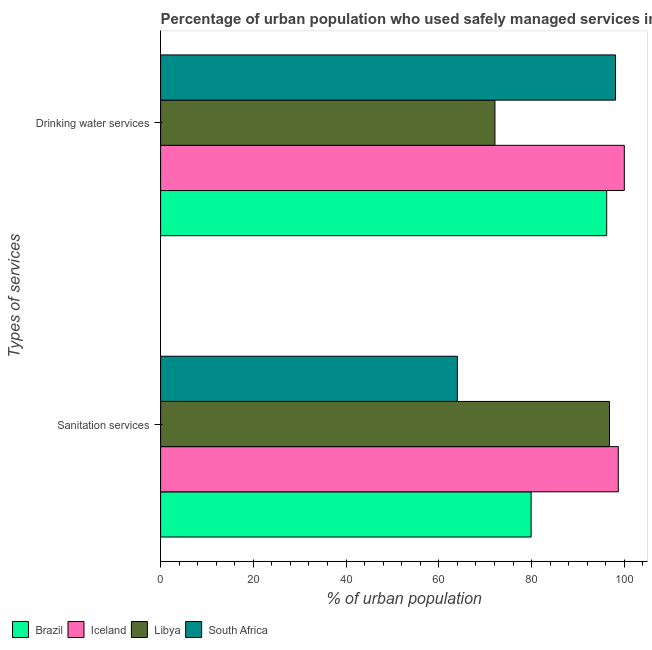How many groups of bars are there?
Offer a very short reply. 2. What is the label of the 2nd group of bars from the top?
Provide a short and direct response. Sanitation services. In which country was the percentage of urban population who used sanitation services minimum?
Make the answer very short. South Africa. What is the total percentage of urban population who used drinking water services in the graph?
Give a very brief answer. 366.4. What is the difference between the percentage of urban population who used drinking water services in Libya and that in Brazil?
Provide a short and direct response. -24.1. What is the difference between the percentage of urban population who used sanitation services in Brazil and the percentage of urban population who used drinking water services in South Africa?
Keep it short and to the point. -18.2. What is the average percentage of urban population who used sanitation services per country?
Offer a very short reply. 84.85. What is the difference between the percentage of urban population who used drinking water services and percentage of urban population who used sanitation services in Brazil?
Make the answer very short. 16.3. In how many countries, is the percentage of urban population who used drinking water services greater than 88 %?
Your answer should be very brief. 3. What does the 2nd bar from the top in Sanitation services represents?
Keep it short and to the point. Libya. What does the 4th bar from the bottom in Sanitation services represents?
Ensure brevity in your answer.  South Africa. Are the values on the major ticks of X-axis written in scientific E-notation?
Offer a terse response. No. Does the graph contain grids?
Ensure brevity in your answer.  No. How many legend labels are there?
Provide a succinct answer. 4. How are the legend labels stacked?
Keep it short and to the point. Horizontal. What is the title of the graph?
Offer a terse response. Percentage of urban population who used safely managed services in 1992. What is the label or title of the X-axis?
Your response must be concise. % of urban population. What is the label or title of the Y-axis?
Provide a succinct answer. Types of services. What is the % of urban population in Brazil in Sanitation services?
Give a very brief answer. 79.9. What is the % of urban population of Iceland in Sanitation services?
Offer a terse response. 98.7. What is the % of urban population of Libya in Sanitation services?
Your answer should be compact. 96.8. What is the % of urban population of South Africa in Sanitation services?
Your response must be concise. 64. What is the % of urban population in Brazil in Drinking water services?
Provide a succinct answer. 96.2. What is the % of urban population of Iceland in Drinking water services?
Ensure brevity in your answer.  100. What is the % of urban population of Libya in Drinking water services?
Provide a succinct answer. 72.1. What is the % of urban population of South Africa in Drinking water services?
Your response must be concise. 98.1. Across all Types of services, what is the maximum % of urban population in Brazil?
Give a very brief answer. 96.2. Across all Types of services, what is the maximum % of urban population of Iceland?
Give a very brief answer. 100. Across all Types of services, what is the maximum % of urban population in Libya?
Your response must be concise. 96.8. Across all Types of services, what is the maximum % of urban population of South Africa?
Offer a very short reply. 98.1. Across all Types of services, what is the minimum % of urban population in Brazil?
Your answer should be very brief. 79.9. Across all Types of services, what is the minimum % of urban population in Iceland?
Your answer should be very brief. 98.7. Across all Types of services, what is the minimum % of urban population of Libya?
Offer a very short reply. 72.1. Across all Types of services, what is the minimum % of urban population in South Africa?
Offer a very short reply. 64. What is the total % of urban population of Brazil in the graph?
Provide a short and direct response. 176.1. What is the total % of urban population of Iceland in the graph?
Provide a short and direct response. 198.7. What is the total % of urban population in Libya in the graph?
Offer a terse response. 168.9. What is the total % of urban population in South Africa in the graph?
Offer a very short reply. 162.1. What is the difference between the % of urban population of Brazil in Sanitation services and that in Drinking water services?
Provide a succinct answer. -16.3. What is the difference between the % of urban population in Libya in Sanitation services and that in Drinking water services?
Provide a short and direct response. 24.7. What is the difference between the % of urban population in South Africa in Sanitation services and that in Drinking water services?
Make the answer very short. -34.1. What is the difference between the % of urban population in Brazil in Sanitation services and the % of urban population in Iceland in Drinking water services?
Offer a very short reply. -20.1. What is the difference between the % of urban population of Brazil in Sanitation services and the % of urban population of South Africa in Drinking water services?
Your answer should be compact. -18.2. What is the difference between the % of urban population of Iceland in Sanitation services and the % of urban population of Libya in Drinking water services?
Offer a very short reply. 26.6. What is the difference between the % of urban population of Iceland in Sanitation services and the % of urban population of South Africa in Drinking water services?
Keep it short and to the point. 0.6. What is the average % of urban population in Brazil per Types of services?
Your answer should be compact. 88.05. What is the average % of urban population of Iceland per Types of services?
Your answer should be very brief. 99.35. What is the average % of urban population of Libya per Types of services?
Your response must be concise. 84.45. What is the average % of urban population of South Africa per Types of services?
Offer a terse response. 81.05. What is the difference between the % of urban population in Brazil and % of urban population in Iceland in Sanitation services?
Your answer should be very brief. -18.8. What is the difference between the % of urban population of Brazil and % of urban population of Libya in Sanitation services?
Give a very brief answer. -16.9. What is the difference between the % of urban population of Brazil and % of urban population of South Africa in Sanitation services?
Your answer should be compact. 15.9. What is the difference between the % of urban population of Iceland and % of urban population of South Africa in Sanitation services?
Provide a succinct answer. 34.7. What is the difference between the % of urban population of Libya and % of urban population of South Africa in Sanitation services?
Your answer should be compact. 32.8. What is the difference between the % of urban population of Brazil and % of urban population of Libya in Drinking water services?
Your answer should be very brief. 24.1. What is the difference between the % of urban population in Iceland and % of urban population in Libya in Drinking water services?
Your answer should be compact. 27.9. What is the difference between the % of urban population of Iceland and % of urban population of South Africa in Drinking water services?
Provide a short and direct response. 1.9. What is the difference between the % of urban population of Libya and % of urban population of South Africa in Drinking water services?
Provide a short and direct response. -26. What is the ratio of the % of urban population of Brazil in Sanitation services to that in Drinking water services?
Offer a terse response. 0.83. What is the ratio of the % of urban population in Iceland in Sanitation services to that in Drinking water services?
Your response must be concise. 0.99. What is the ratio of the % of urban population of Libya in Sanitation services to that in Drinking water services?
Your answer should be compact. 1.34. What is the ratio of the % of urban population in South Africa in Sanitation services to that in Drinking water services?
Your answer should be compact. 0.65. What is the difference between the highest and the second highest % of urban population of Brazil?
Ensure brevity in your answer.  16.3. What is the difference between the highest and the second highest % of urban population of Iceland?
Offer a terse response. 1.3. What is the difference between the highest and the second highest % of urban population of Libya?
Your answer should be compact. 24.7. What is the difference between the highest and the second highest % of urban population in South Africa?
Provide a short and direct response. 34.1. What is the difference between the highest and the lowest % of urban population in Iceland?
Your answer should be very brief. 1.3. What is the difference between the highest and the lowest % of urban population in Libya?
Provide a short and direct response. 24.7. What is the difference between the highest and the lowest % of urban population in South Africa?
Your answer should be very brief. 34.1. 